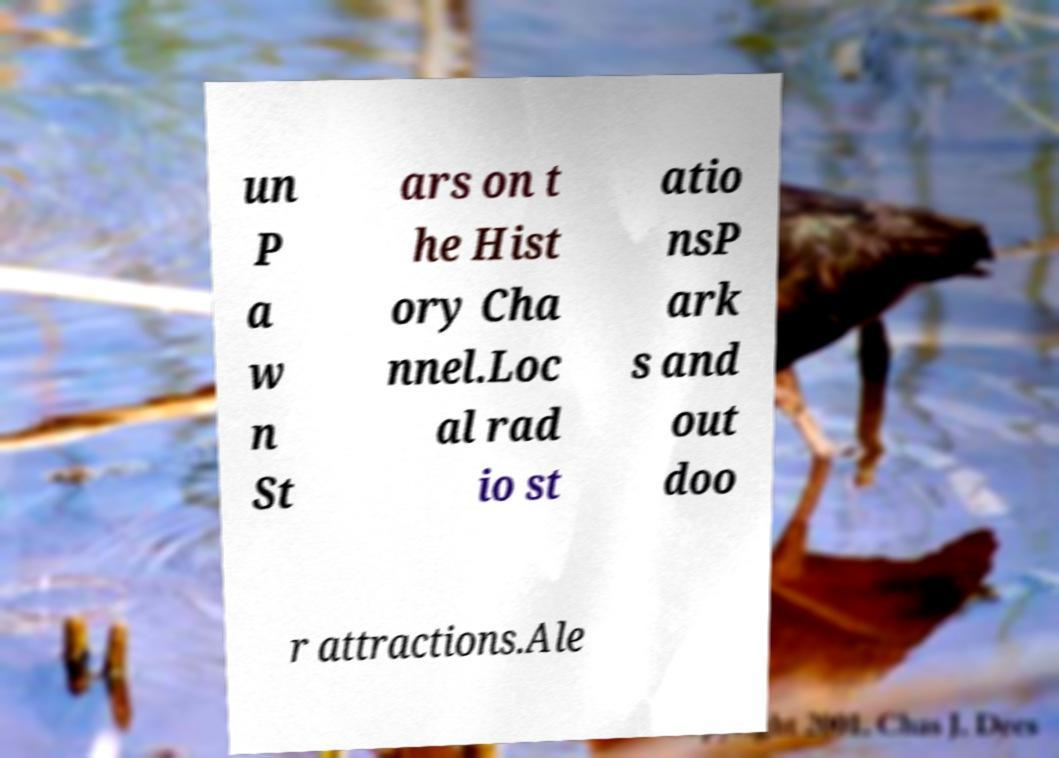What messages or text are displayed in this image? I need them in a readable, typed format. un P a w n St ars on t he Hist ory Cha nnel.Loc al rad io st atio nsP ark s and out doo r attractions.Ale 